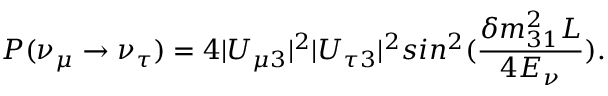<formula> <loc_0><loc_0><loc_500><loc_500>P ( \nu _ { \mu } \rightarrow \nu _ { \tau } ) = 4 | U _ { \mu 3 } | ^ { 2 } | U _ { \tau 3 } | ^ { 2 } \sin ^ { 2 } ( \frac { \delta m _ { 3 1 } ^ { 2 } L } { 4 E _ { \nu } } ) .</formula> 